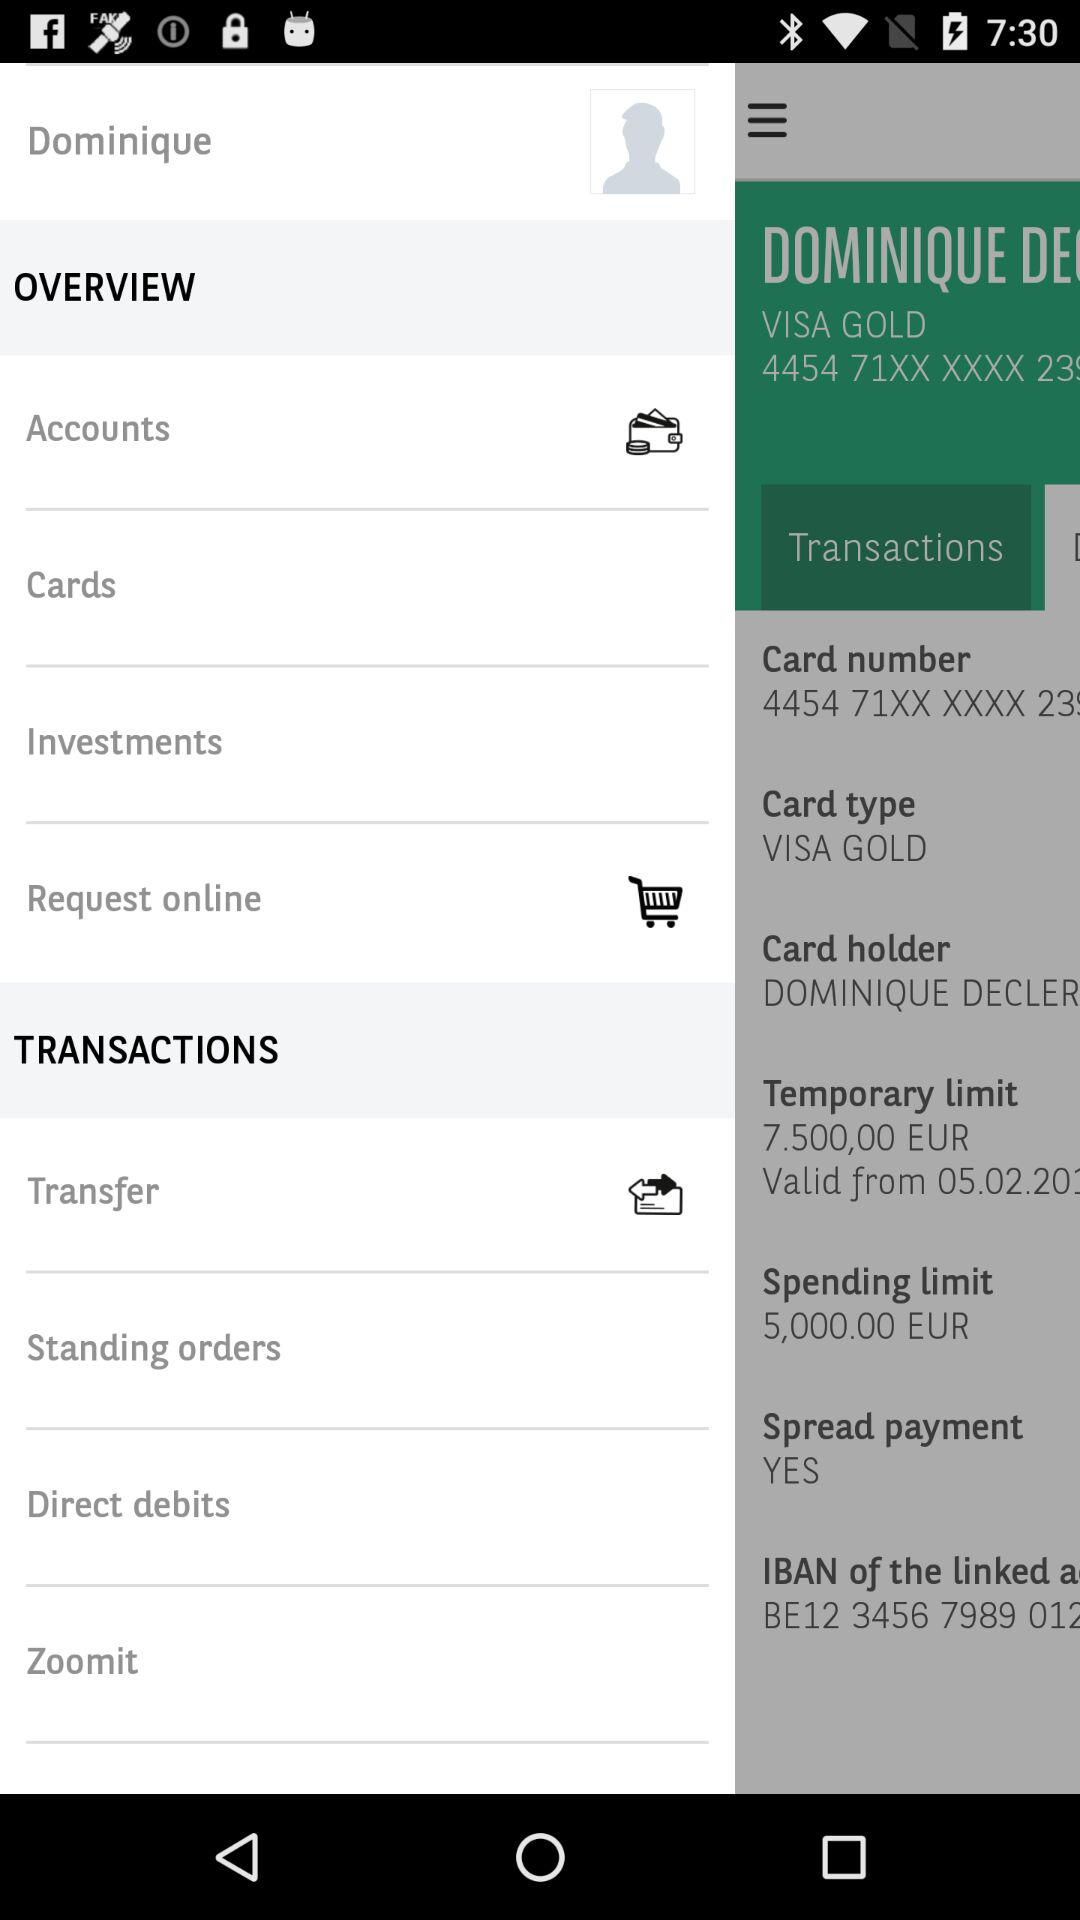What is the temporary limit? The temporary limit is 7.500,00 EUR. 